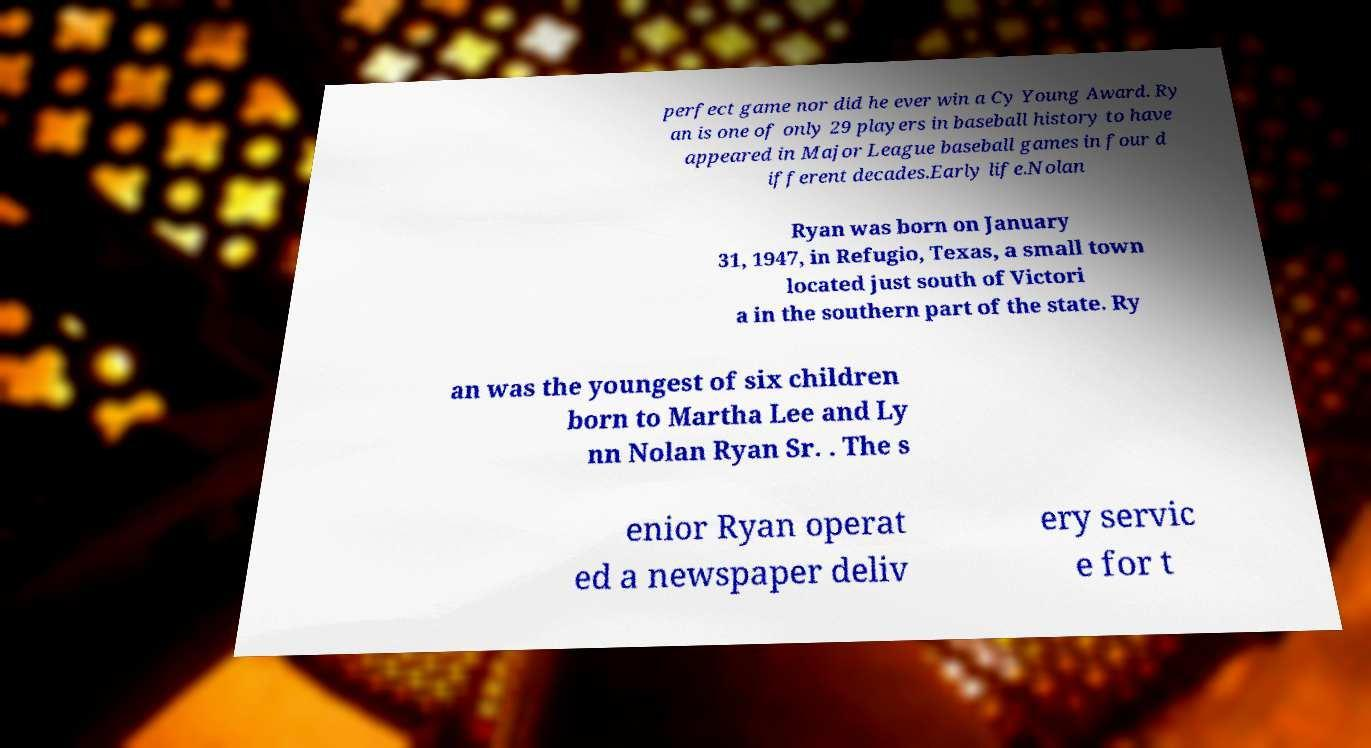Can you accurately transcribe the text from the provided image for me? perfect game nor did he ever win a Cy Young Award. Ry an is one of only 29 players in baseball history to have appeared in Major League baseball games in four d ifferent decades.Early life.Nolan Ryan was born on January 31, 1947, in Refugio, Texas, a small town located just south of Victori a in the southern part of the state. Ry an was the youngest of six children born to Martha Lee and Ly nn Nolan Ryan Sr. . The s enior Ryan operat ed a newspaper deliv ery servic e for t 